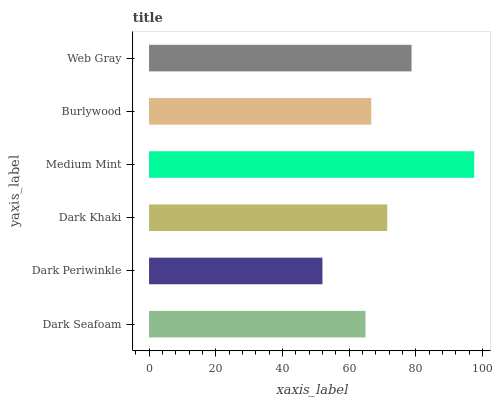Is Dark Periwinkle the minimum?
Answer yes or no. Yes. Is Medium Mint the maximum?
Answer yes or no. Yes. Is Dark Khaki the minimum?
Answer yes or no. No. Is Dark Khaki the maximum?
Answer yes or no. No. Is Dark Khaki greater than Dark Periwinkle?
Answer yes or no. Yes. Is Dark Periwinkle less than Dark Khaki?
Answer yes or no. Yes. Is Dark Periwinkle greater than Dark Khaki?
Answer yes or no. No. Is Dark Khaki less than Dark Periwinkle?
Answer yes or no. No. Is Dark Khaki the high median?
Answer yes or no. Yes. Is Burlywood the low median?
Answer yes or no. Yes. Is Dark Periwinkle the high median?
Answer yes or no. No. Is Dark Khaki the low median?
Answer yes or no. No. 